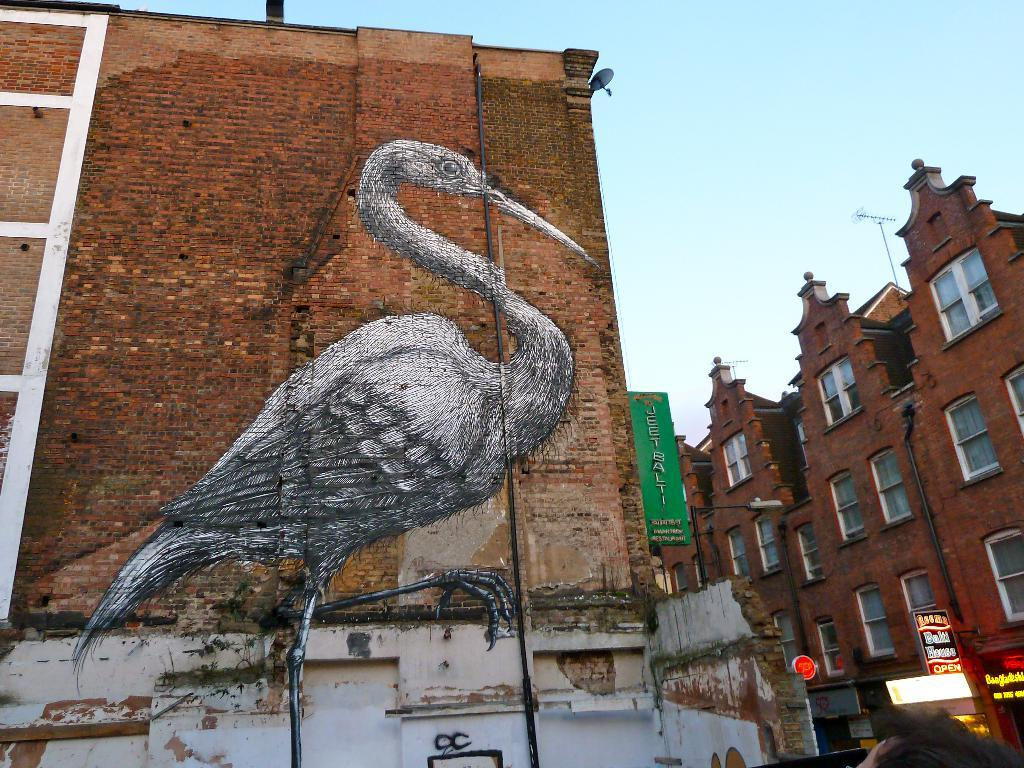What type of structure is depicted in the image? There is a brick wall in the image. What is featured on the brick wall? There is an art of a bird on the brick wall. What other objects can be seen in the image? There is a board and light poles in the image. What can be seen in the background of the image? There are buildings and the sky visible in the background of the image. What type of shame can be seen on the bird's face in the image? There is no shame depicted on the bird's face in the image, as it is an art piece and not a living creature. Can you tell me how many beetles are crawling on the board in the image? There are no beetles present in the image; the board is a separate object from the brick wall and the bird art. 